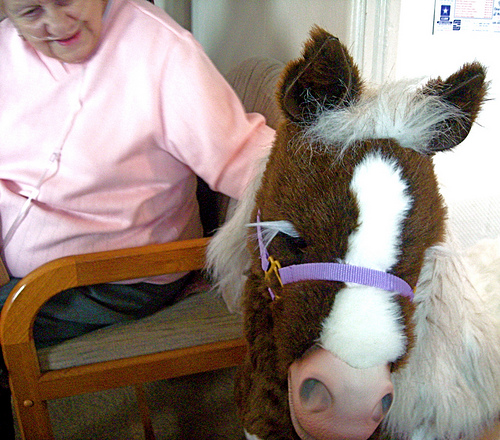<image>
Is the woman behind the pony? Yes. From this viewpoint, the woman is positioned behind the pony, with the pony partially or fully occluding the woman. Is the horse to the left of the owner? No. The horse is not to the left of the owner. From this viewpoint, they have a different horizontal relationship. 